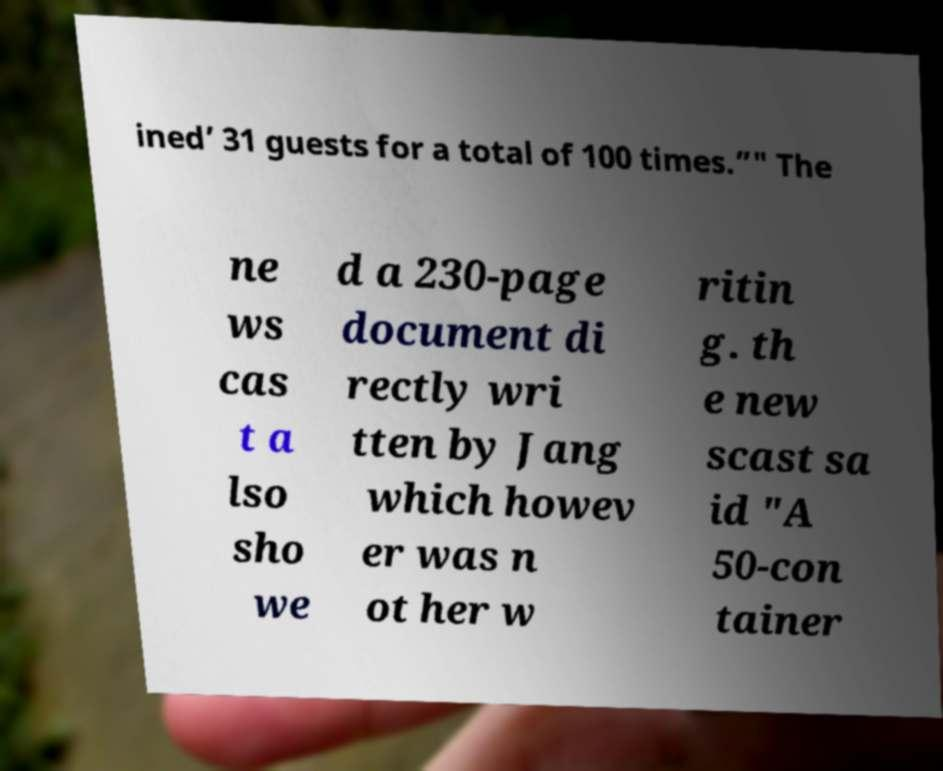Could you assist in decoding the text presented in this image and type it out clearly? ined’ 31 guests for a total of 100 times.”" The ne ws cas t a lso sho we d a 230-page document di rectly wri tten by Jang which howev er was n ot her w ritin g. th e new scast sa id "A 50-con tainer 